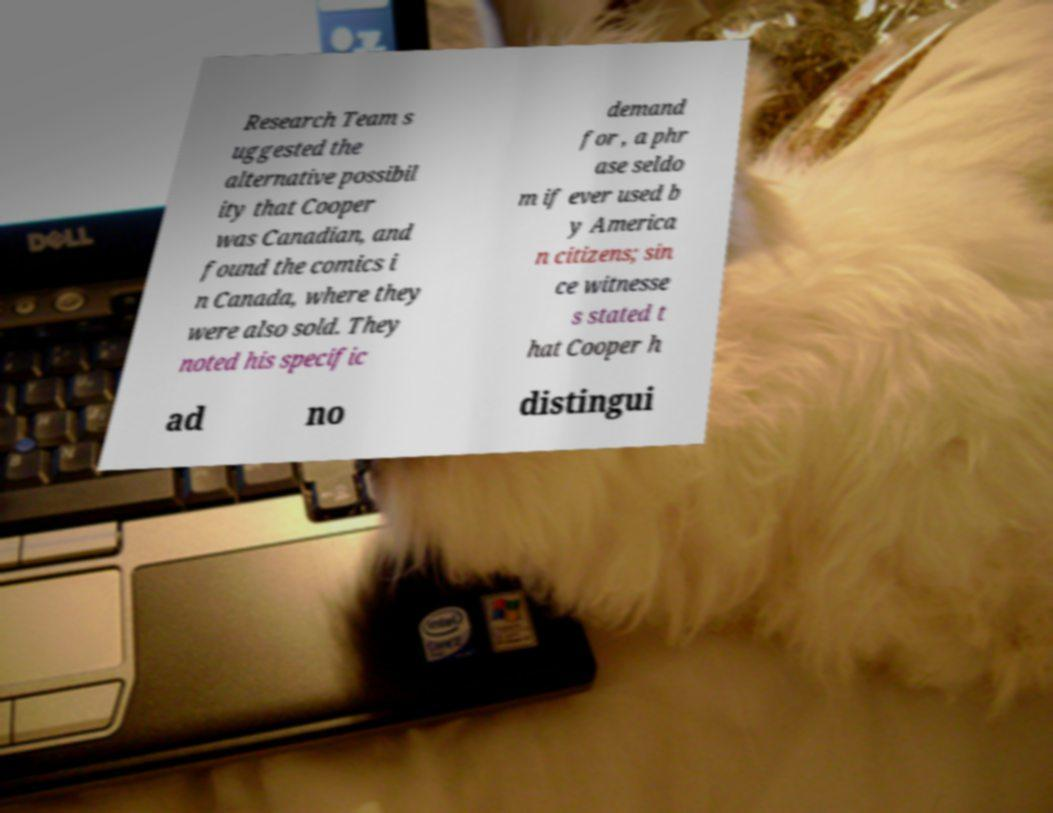Can you read and provide the text displayed in the image?This photo seems to have some interesting text. Can you extract and type it out for me? Research Team s uggested the alternative possibil ity that Cooper was Canadian, and found the comics i n Canada, where they were also sold. They noted his specific demand for , a phr ase seldo m if ever used b y America n citizens; sin ce witnesse s stated t hat Cooper h ad no distingui 